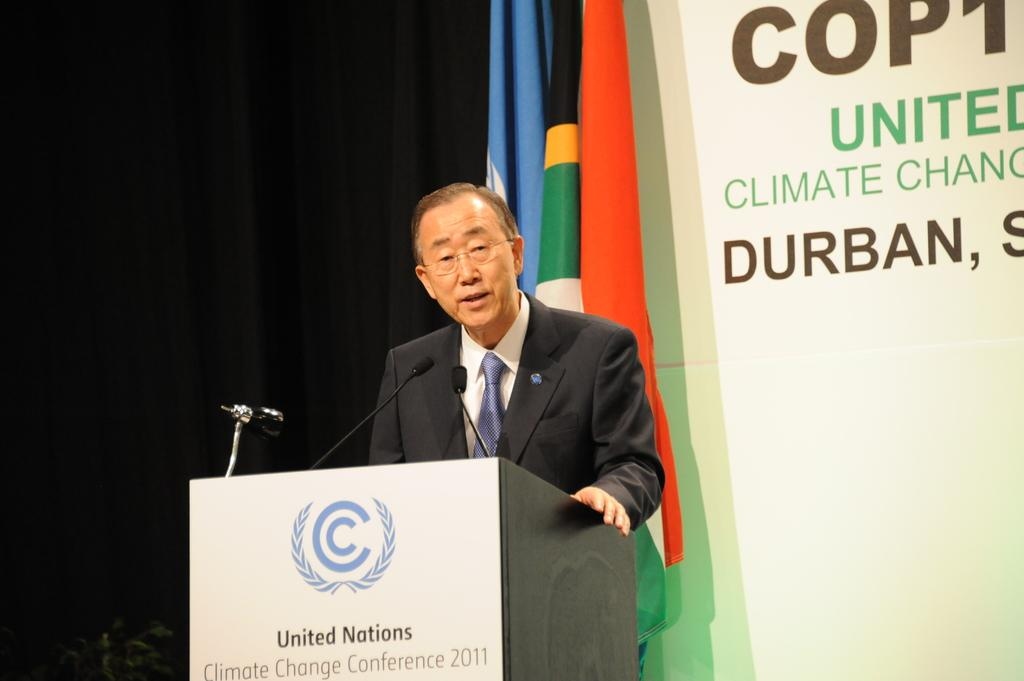What is the man in the image doing near the podium? The man is standing near a podium in the image. What is in front of the man that he might use for speaking? There is a microphone with a stand in front of the man. What can be seen in the background or surroundings of the image? Flags are visible in the image. How is the man dressed in the image? The man is wearing a formal suit. How many frogs are hopping around the man in the image? There are no frogs present in the image. What type of debt is the man discussing in the image? The image does not provide any information about the man's discussion or topic, so it cannot be determined if he is discussing debt. 